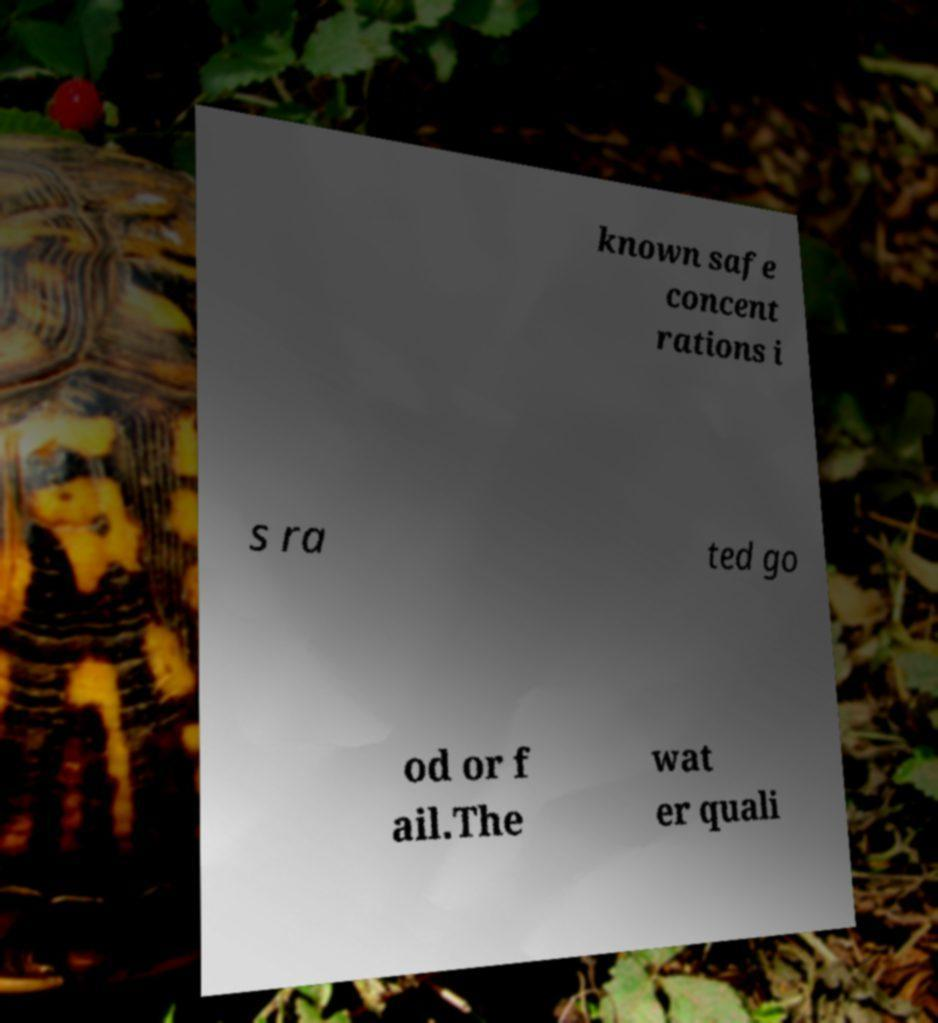Could you extract and type out the text from this image? known safe concent rations i s ra ted go od or f ail.The wat er quali 